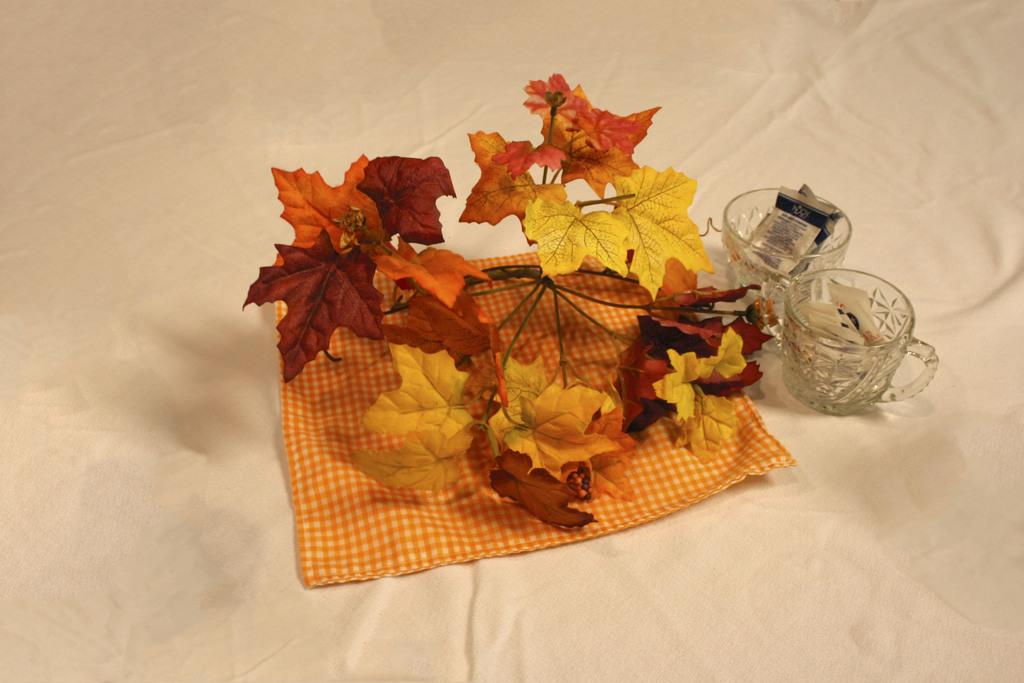What type of material is visible in the image? There is a white cloth in the image. What objects are present that can be used for drinking? There are glasses in the image. What type of natural scenery can be seen in the image? There are trees in the image. Where is the grandmother sitting in the image? There is no grandmother present in the image. What type of transportation is flying in the image? There is no plane or any type of transportation present in the image. 